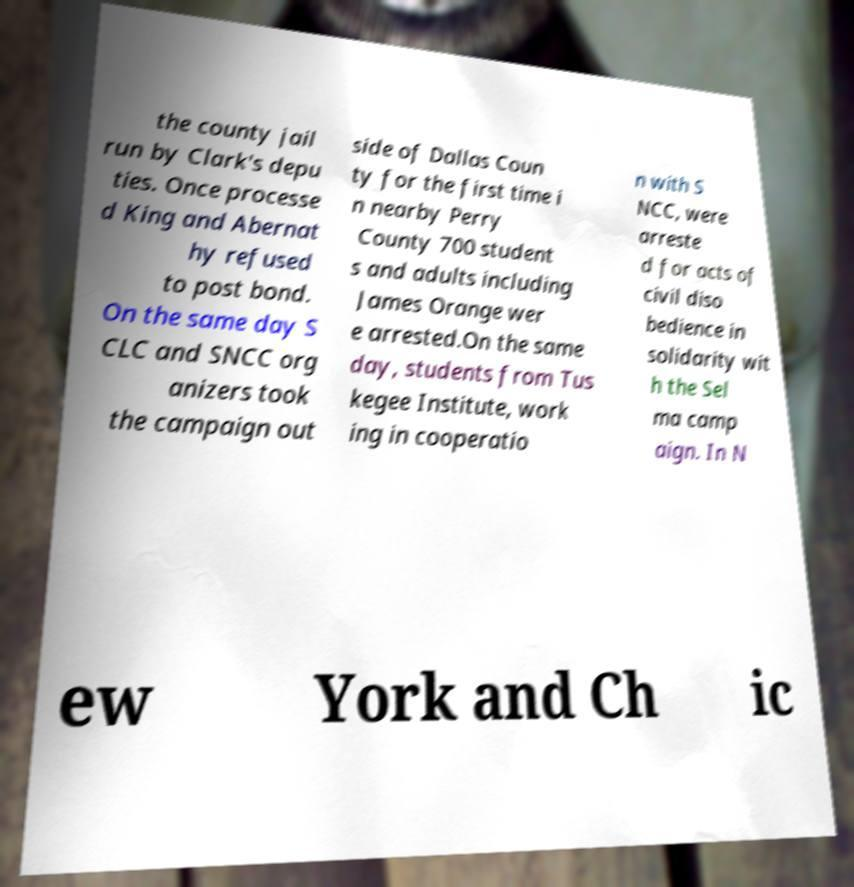Can you read and provide the text displayed in the image?This photo seems to have some interesting text. Can you extract and type it out for me? the county jail run by Clark's depu ties. Once processe d King and Abernat hy refused to post bond. On the same day S CLC and SNCC org anizers took the campaign out side of Dallas Coun ty for the first time i n nearby Perry County 700 student s and adults including James Orange wer e arrested.On the same day, students from Tus kegee Institute, work ing in cooperatio n with S NCC, were arreste d for acts of civil diso bedience in solidarity wit h the Sel ma camp aign. In N ew York and Ch ic 